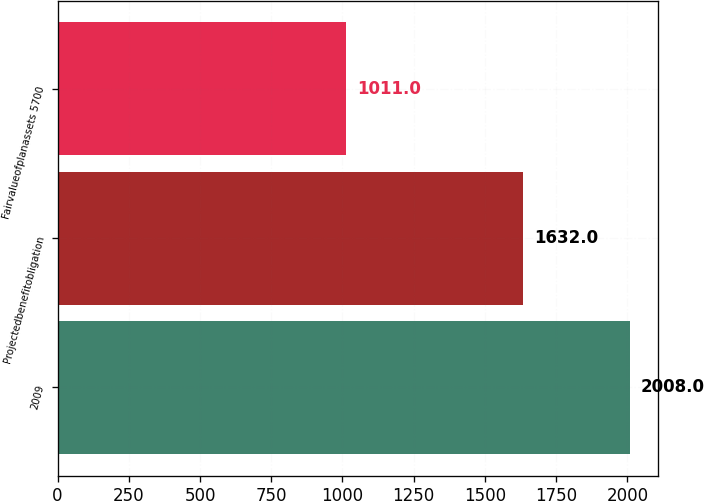Convert chart. <chart><loc_0><loc_0><loc_500><loc_500><bar_chart><fcel>2009<fcel>Projectedbenefitobligation<fcel>Fairvalueofplanassets 5700<nl><fcel>2008<fcel>1632<fcel>1011<nl></chart> 